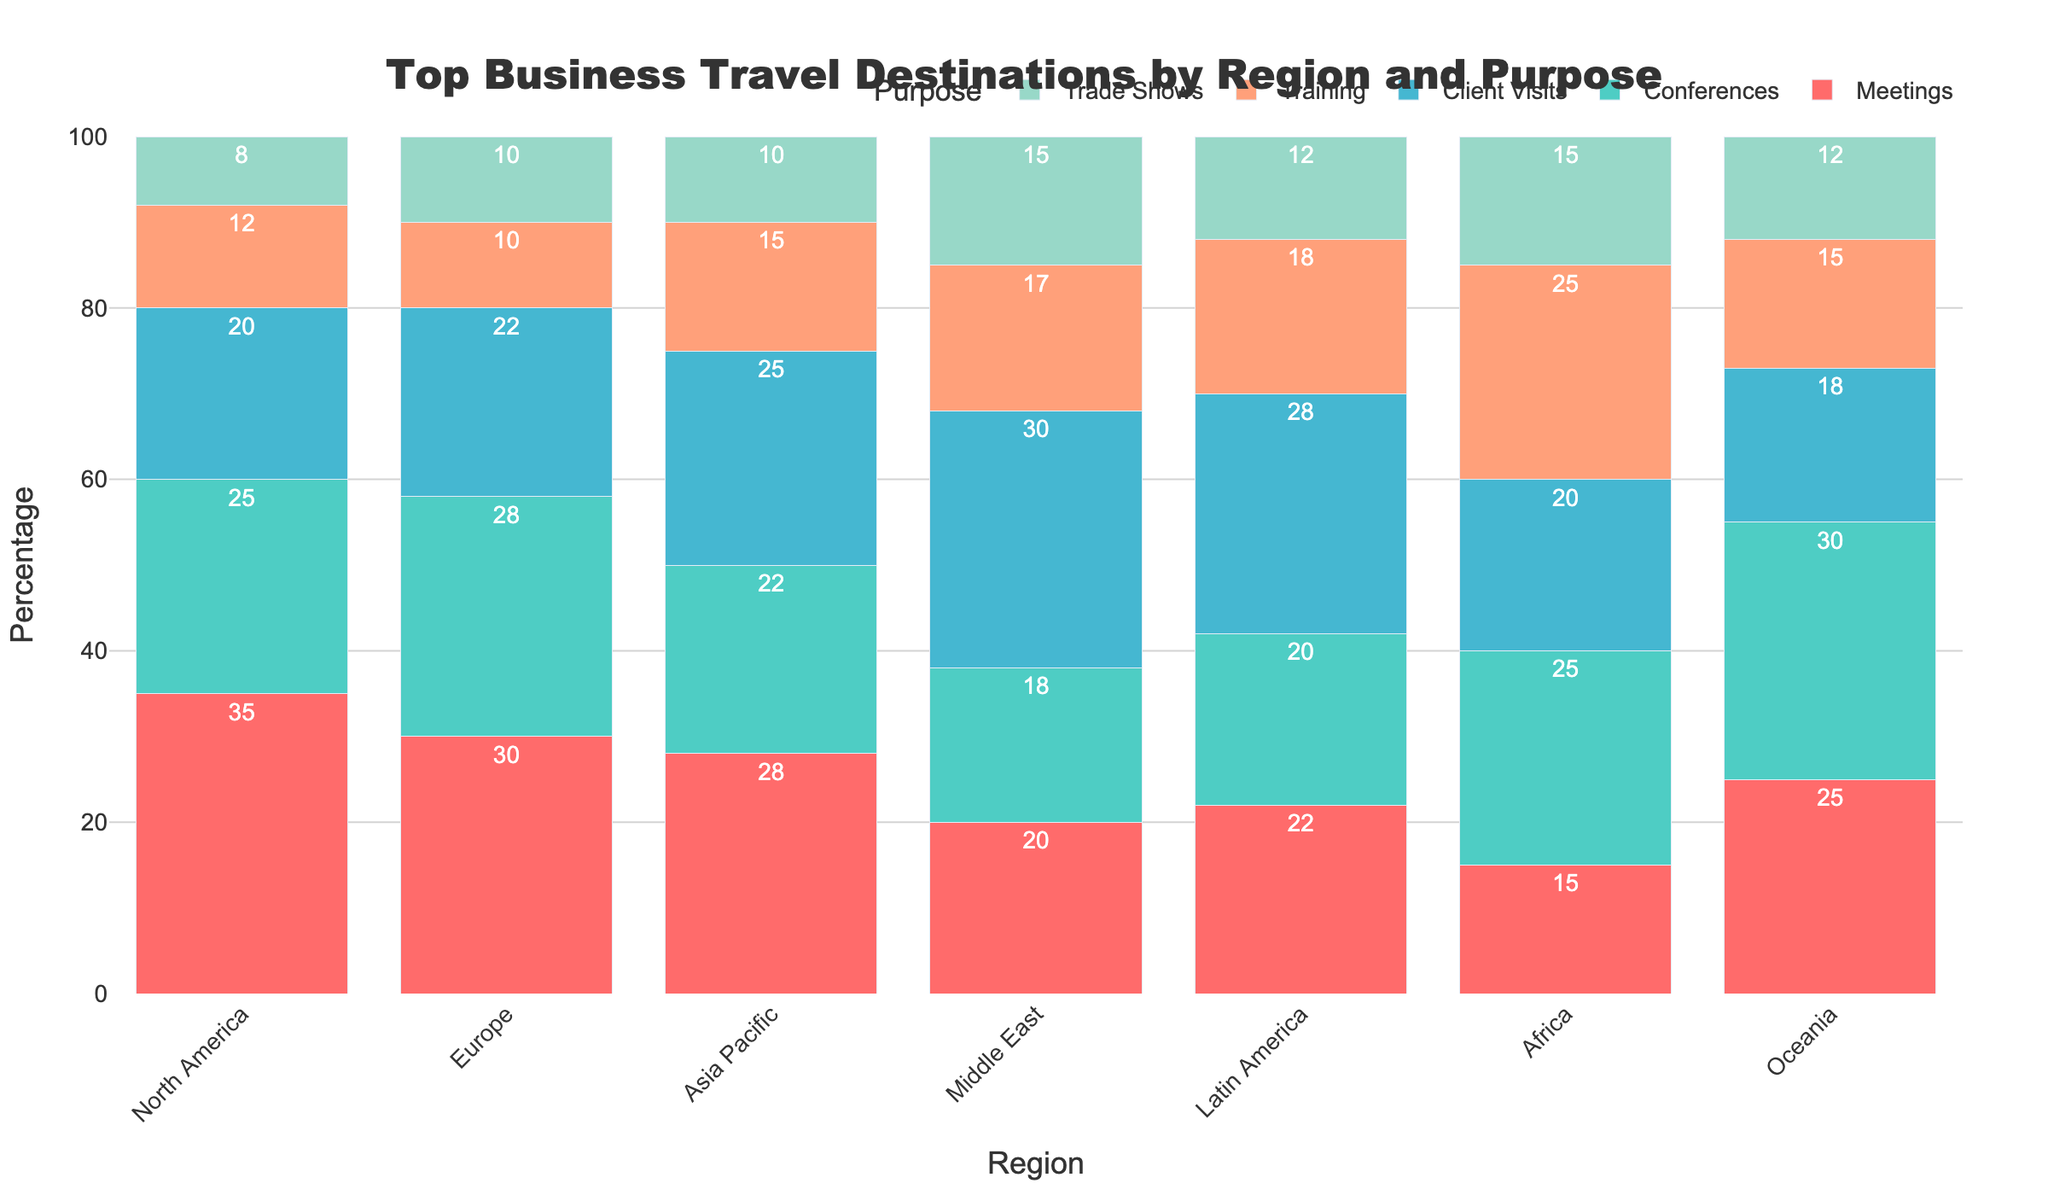What is the total percentage of client visits across all regions? To find the total percentage of client visits, sum the values for client visits across all regions: North America (20) + Europe (22) + Asia Pacific (25) + Middle East (30) + Latin America (28) + Africa (20) + Oceania (18) = 163
Answer: 163 Which region has the highest percentage for trade shows? Compare the percentages for trade shows across all regions: North America (8), Europe (10), Asia Pacific (10), Middle East (15), Latin America (12), Africa (15), and Oceania (12). The Middle East and Africa both have the highest value at 15.
Answer: Middle East, Africa Out of North America and Europe, which region has a higher percentage for training purposes? Compare the percentage of training in North America and Europe: North America (12) and Europe (10). North America has the higher value.
Answer: North America What is the combined percentage of conferences and trade shows for the Asia Pacific region? Sum the percentages for conferences and trade shows in Asia Pacific: Conferences (22) + Trade Shows (10) = 32
Answer: 32 What is the average percentage of meetings across all regions? Sum the percentages of meetings across all regions and divide by the number of regions: (35 + 30 + 28 + 20 + 22 + 15 + 25) / 7 = 175 / 7 = 25
Answer: 25 Between Europe and Latin America, which region has a higher combined percentage for client visits and training? Calculate the combined percentages for client visits and training in Europe and Latin America:
Europe: Client Visits (22) + Training (10) = 32
Latin America: Client Visits (28) + Training (18) = 46
Latin America has the higher value.
Answer: Latin America Which region has the lowest total percentage of all purposes combined? Sum the percentages for all purposes in each region and find the one with the lowest sum:
North America: 35 + 25 + 20 + 12 + 8 = 100
Europe: 30 + 28 + 22 + 10 + 10 = 100
Asia Pacific: 28 + 22 + 25 + 15 + 10 = 100
Middle East: 20 + 18 + 30 + 17 + 15 = 100
Latin America: 22 + 20 + 28 + 18 + 12 = 100
Africa: 15 + 25 + 20 + 25 + 15 = 100
Oceania: 25 + 30 + 18 + 15 + 12 = 100
All regions have a total percentage of 100, so none have a lower sum than others.
Answer: All are equal 